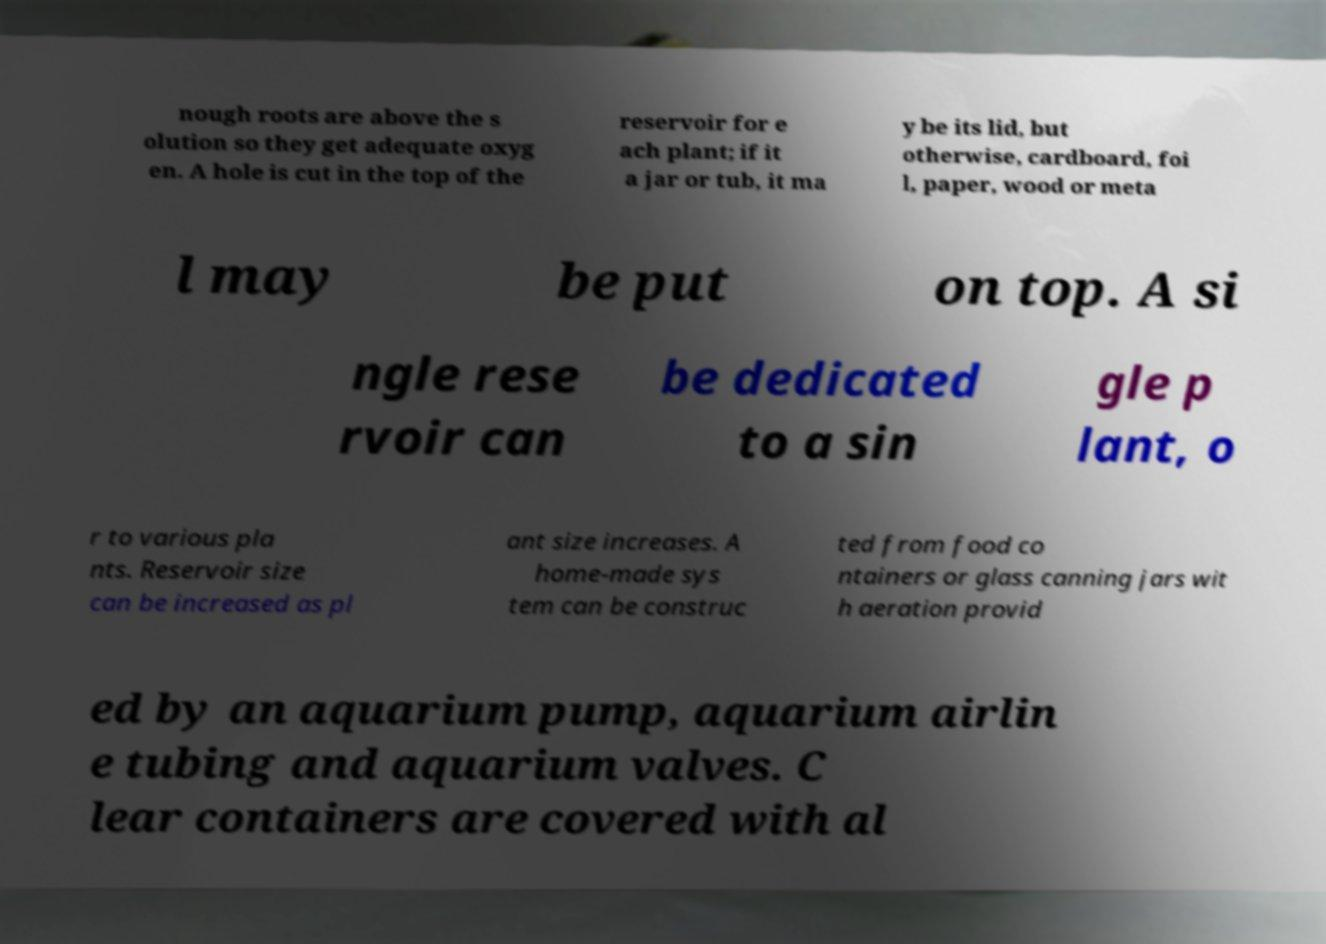Can you accurately transcribe the text from the provided image for me? nough roots are above the s olution so they get adequate oxyg en. A hole is cut in the top of the reservoir for e ach plant; if it a jar or tub, it ma y be its lid, but otherwise, cardboard, foi l, paper, wood or meta l may be put on top. A si ngle rese rvoir can be dedicated to a sin gle p lant, o r to various pla nts. Reservoir size can be increased as pl ant size increases. A home-made sys tem can be construc ted from food co ntainers or glass canning jars wit h aeration provid ed by an aquarium pump, aquarium airlin e tubing and aquarium valves. C lear containers are covered with al 